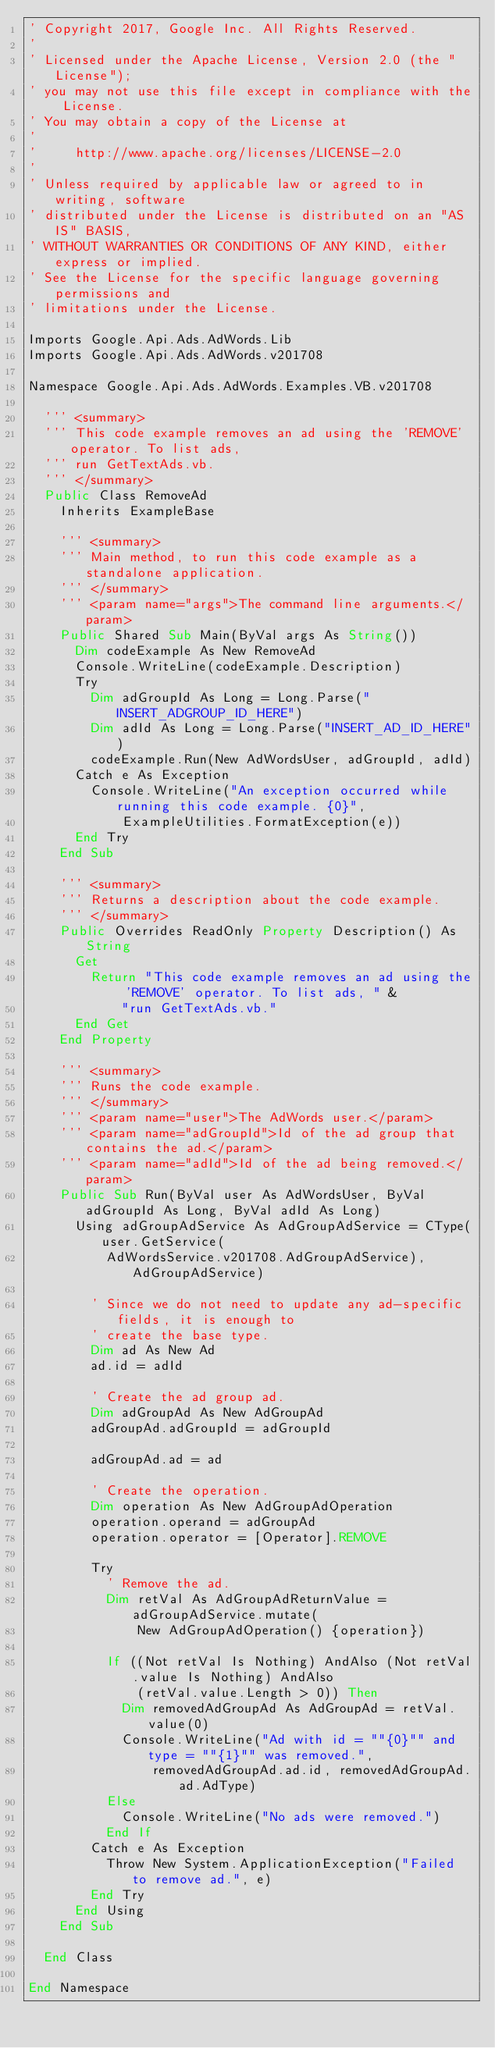<code> <loc_0><loc_0><loc_500><loc_500><_VisualBasic_>' Copyright 2017, Google Inc. All Rights Reserved.
'
' Licensed under the Apache License, Version 2.0 (the "License");
' you may not use this file except in compliance with the License.
' You may obtain a copy of the License at
'
'     http://www.apache.org/licenses/LICENSE-2.0
'
' Unless required by applicable law or agreed to in writing, software
' distributed under the License is distributed on an "AS IS" BASIS,
' WITHOUT WARRANTIES OR CONDITIONS OF ANY KIND, either express or implied.
' See the License for the specific language governing permissions and
' limitations under the License.

Imports Google.Api.Ads.AdWords.Lib
Imports Google.Api.Ads.AdWords.v201708

Namespace Google.Api.Ads.AdWords.Examples.VB.v201708

  ''' <summary>
  ''' This code example removes an ad using the 'REMOVE' operator. To list ads,
  ''' run GetTextAds.vb.
  ''' </summary>
  Public Class RemoveAd
    Inherits ExampleBase

    ''' <summary>
    ''' Main method, to run this code example as a standalone application.
    ''' </summary>
    ''' <param name="args">The command line arguments.</param>
    Public Shared Sub Main(ByVal args As String())
      Dim codeExample As New RemoveAd
      Console.WriteLine(codeExample.Description)
      Try
        Dim adGroupId As Long = Long.Parse("INSERT_ADGROUP_ID_HERE")
        Dim adId As Long = Long.Parse("INSERT_AD_ID_HERE")
        codeExample.Run(New AdWordsUser, adGroupId, adId)
      Catch e As Exception
        Console.WriteLine("An exception occurred while running this code example. {0}",
            ExampleUtilities.FormatException(e))
      End Try
    End Sub

    ''' <summary>
    ''' Returns a description about the code example.
    ''' </summary>
    Public Overrides ReadOnly Property Description() As String
      Get
        Return "This code example removes an ad using the 'REMOVE' operator. To list ads, " &
            "run GetTextAds.vb."
      End Get
    End Property

    ''' <summary>
    ''' Runs the code example.
    ''' </summary>
    ''' <param name="user">The AdWords user.</param>
    ''' <param name="adGroupId">Id of the ad group that contains the ad.</param>
    ''' <param name="adId">Id of the ad being removed.</param>
    Public Sub Run(ByVal user As AdWordsUser, ByVal adGroupId As Long, ByVal adId As Long)
      Using adGroupAdService As AdGroupAdService = CType(user.GetService(
          AdWordsService.v201708.AdGroupAdService), AdGroupAdService)

        ' Since we do not need to update any ad-specific fields, it is enough to
        ' create the base type.
        Dim ad As New Ad
        ad.id = adId

        ' Create the ad group ad.
        Dim adGroupAd As New AdGroupAd
        adGroupAd.adGroupId = adGroupId

        adGroupAd.ad = ad

        ' Create the operation.
        Dim operation As New AdGroupAdOperation
        operation.operand = adGroupAd
        operation.operator = [Operator].REMOVE

        Try
          ' Remove the ad.
          Dim retVal As AdGroupAdReturnValue = adGroupAdService.mutate(
              New AdGroupAdOperation() {operation})

          If ((Not retVal Is Nothing) AndAlso (Not retVal.value Is Nothing) AndAlso
              (retVal.value.Length > 0)) Then
            Dim removedAdGroupAd As AdGroupAd = retVal.value(0)
            Console.WriteLine("Ad with id = ""{0}"" and type = ""{1}"" was removed.",
                removedAdGroupAd.ad.id, removedAdGroupAd.ad.AdType)
          Else
            Console.WriteLine("No ads were removed.")
          End If
        Catch e As Exception
          Throw New System.ApplicationException("Failed to remove ad.", e)
        End Try
      End Using
    End Sub

  End Class

End Namespace
</code> 